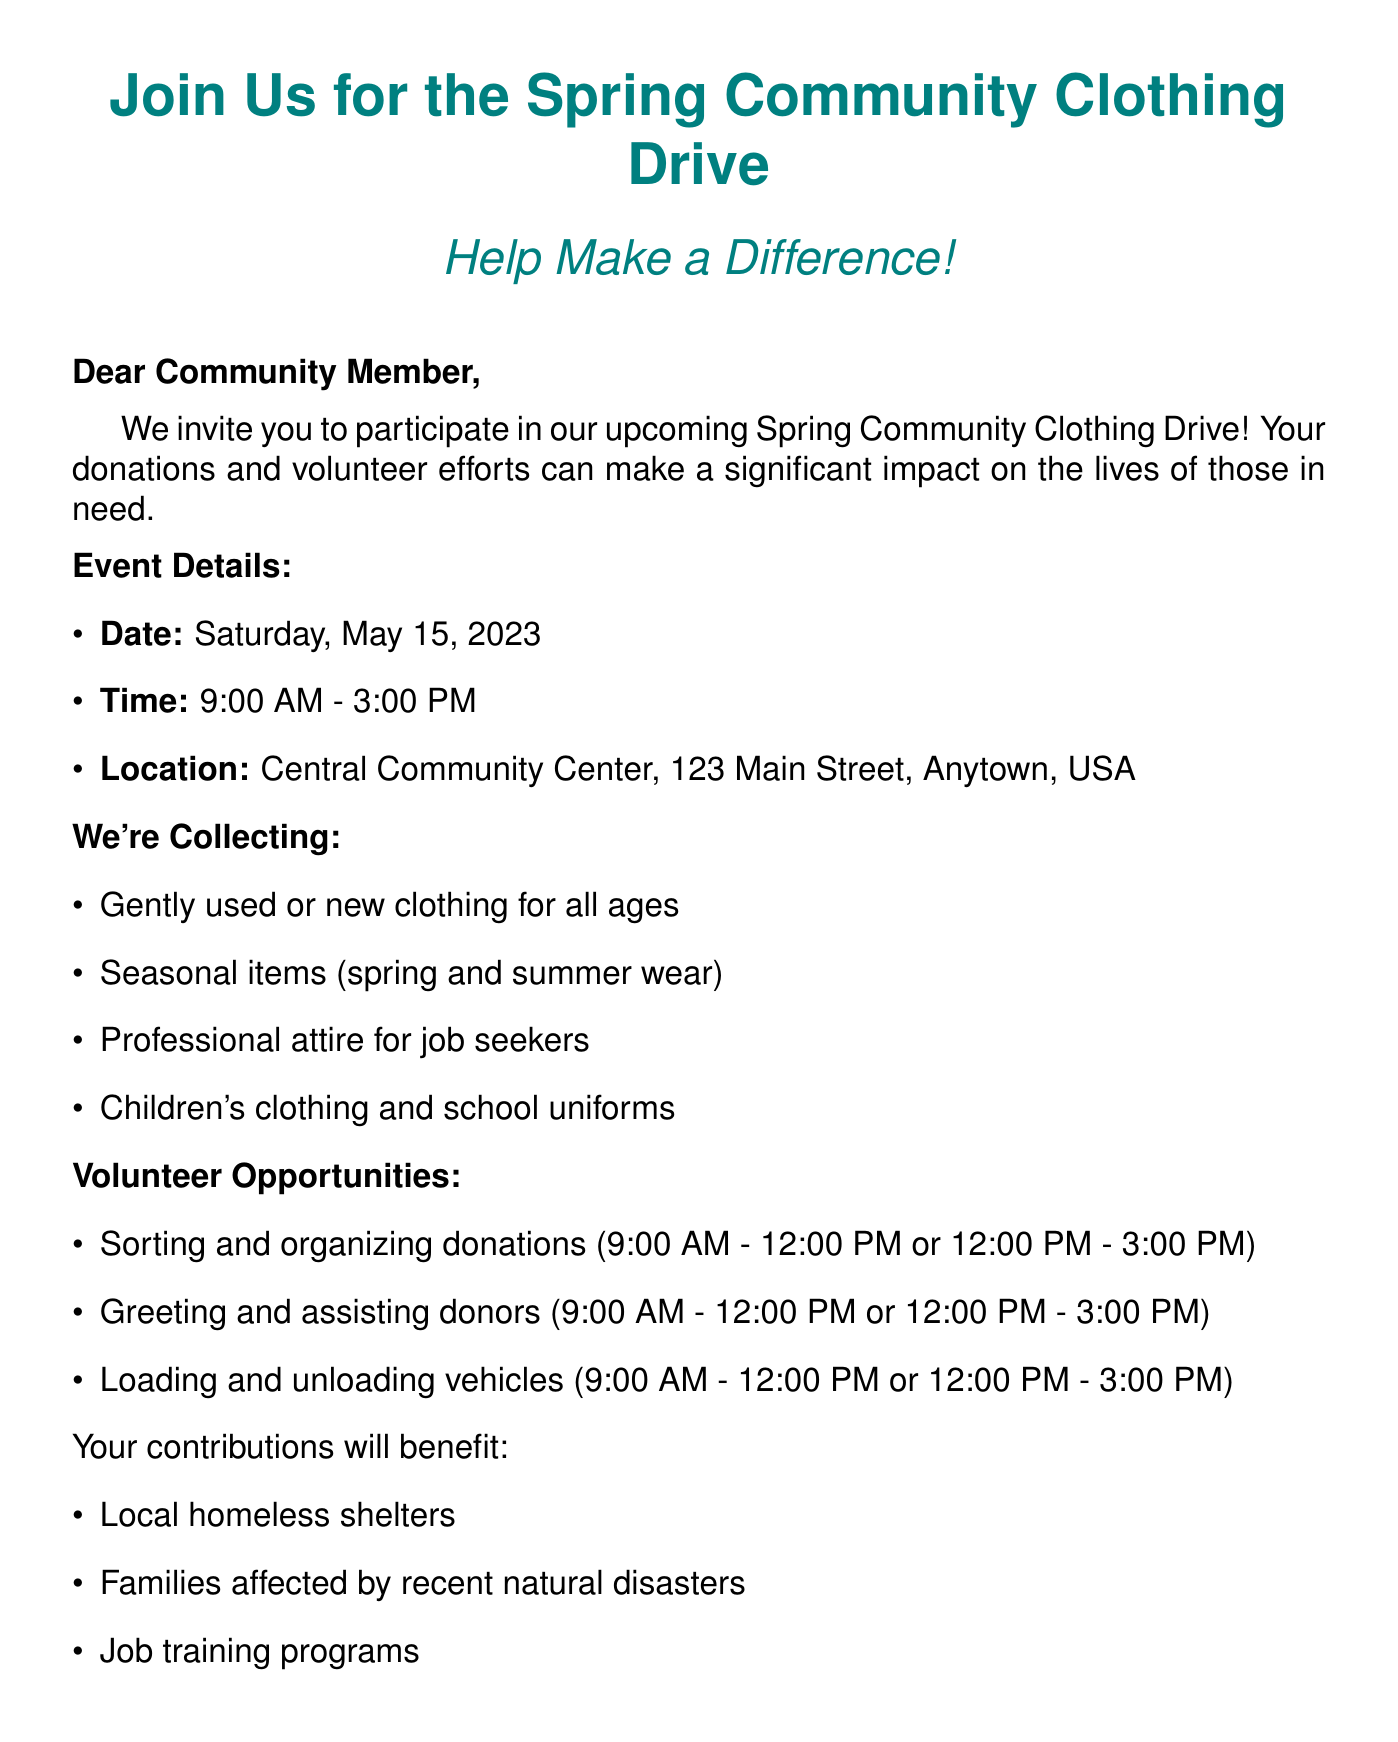What is the date of the clothing drive? The date is specified in the event details section of the document.
Answer: Saturday, May 15, 2023 What are the hours of the event? The document lists the start and end times of the clothing drive in the event details.
Answer: 9:00 AM - 3:00 PM Where is the clothing drive taking place? The location is detailed in the event section of the email.
Answer: Central Community Center, 123 Main Street, Anytown, USA What types of clothing are needed for donations? The specific items needed are listed under the clothing needs section of the document.
Answer: Gently used or new clothing for all ages Who is the contact person for the event? The contact information is provided at the end of the document.
Answer: Sarah Johnson What volunteer role involves helping donors? The document mentions multiple volunteer roles; this specific role is mentioned under volunteer opportunities.
Answer: Greeting and assisting donors Which groups benefit from the clothing drive? The beneficiaries are listed in a dedicated section of the email.
Answer: Local homeless shelters What is provided for volunteers? Additional information in the document mentions something offered to volunteers.
Answer: Light refreshments Are donations tax-deductible? Important information about donations is clearly stated in the additional info section.
Answer: Yes 